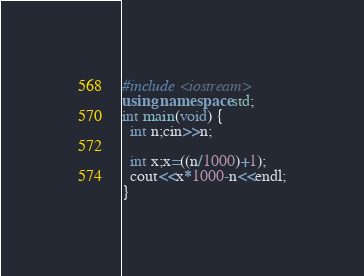<code> <loc_0><loc_0><loc_500><loc_500><_C++_>#include <iostream>
using namespace std;
int main(void) {
  int n;cin>>n;

  int x;x=((n/1000)+1);
  cout<<x*1000-n<<endl;
}</code> 